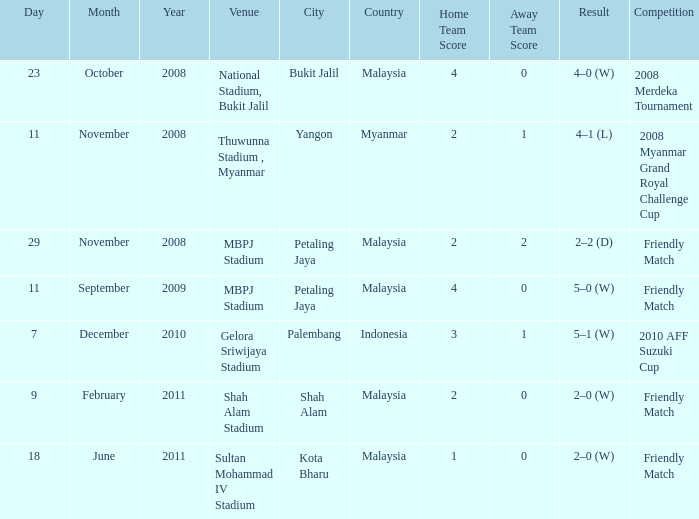What is the Result of the Competition at MBPJ Stadium with a Score of 4–0? 5–0 (W). 